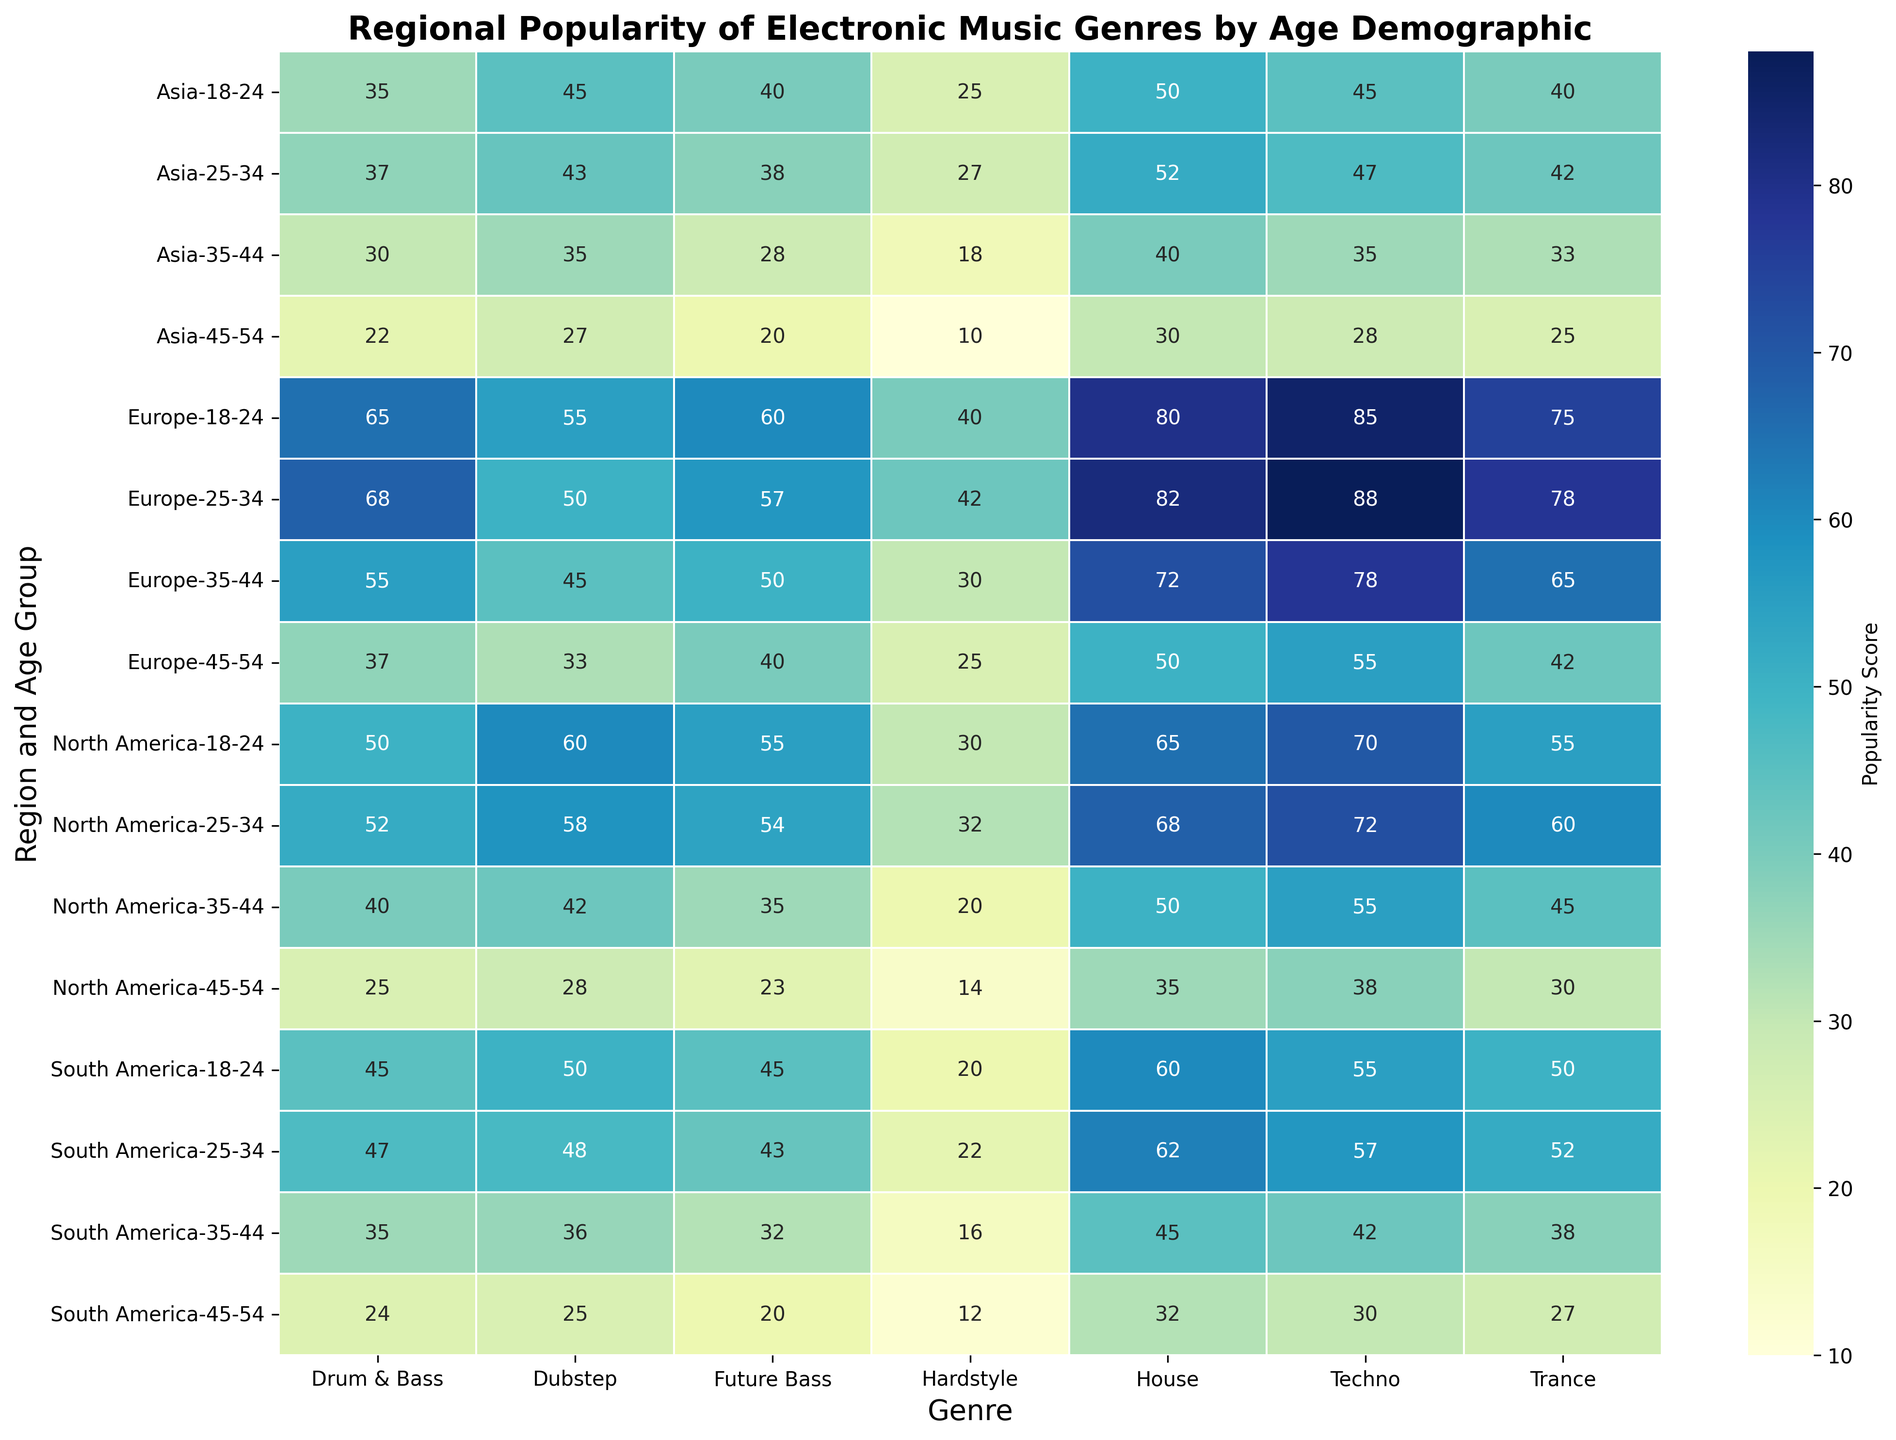Which age group in Europe has the highest popularity score for Techno? Looking at the heatmap, observe the scores for Techno across all age groups in Europe. The highest score is 88 for the age group 25-34.
Answer: 25-34 Compare the popularity of Dubstep between 18-24 in Europe and 18-24 in Asia. Which is higher? Check the heatmap for Dubstep scores. In Europe (18-24), the score is 55, and in Asia (18-24), it is 45. Thus, it is higher in Europe.
Answer: Europe What is the average popularity score for Trance in North America for all age groups? Add the Trance values for each age group in North America (55 + 60 + 45 + 30), then divide by the number of age groups (4): (55 + 60 + 45 + 30) / 4 = 47.5.
Answer: 47.5 Which region has the lowest popularity score for Hardstyle in the 35-44 age group? Examine Hardstyle scores in the heatmap for 35-44: North America (20), Europe (30), Asia (18), South America (16). The lowest is South America.
Answer: South America Arrange the regions in ascending order of the popularity score for Future Bass in the 25-34 age group. Check Future Bass scores for 25-34: North America (54), Europe (57), Asia (38), South America (43). Ascending order: Asia, South America, North America, Europe.
Answer: Asia, South America, North America, Europe What is the combined popularity score for House and Techno among 18-24 in North America? Add the House and Techno scores for North America in the 18-24 group: 65 (House) + 70 (Techno) = 135.
Answer: 135 Which age group in Asia has the highest popularity score for any genre? Locate the highest score in any genre for each age group in Asia. The highest is House (52) for the 25-34 age group.
Answer: 25-34 Is there any age group where Drum & Bass is more popular than House in South America? Compare Drum & Bass scores to House scores in South America across age groups. In all groups, House has a higher or equal score to Drum & Bass.
Answer: No What is the difference in the popularity score of Future Bass between the 18-24 and 45-54 age groups in Europe? Subtract Future Bass score for 45-54 from the score for 18-24 in Europe: 60 - 40 = 20.
Answer: 20 